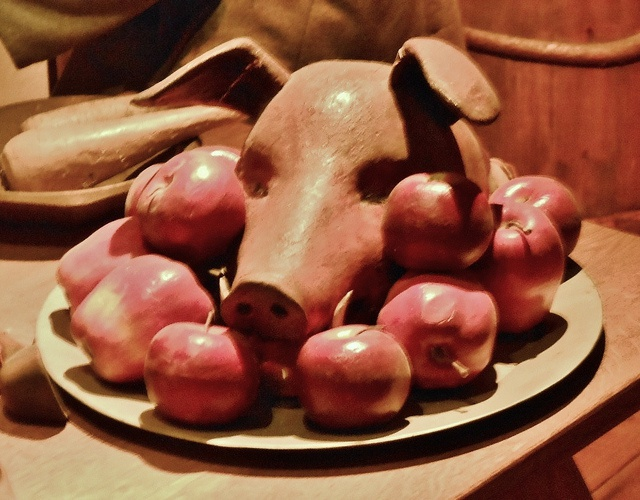Describe the objects in this image and their specific colors. I can see dining table in olive, black, maroon, and tan tones, apple in olive, maroon, brown, black, and salmon tones, and apple in olive, salmon, tan, and beige tones in this image. 